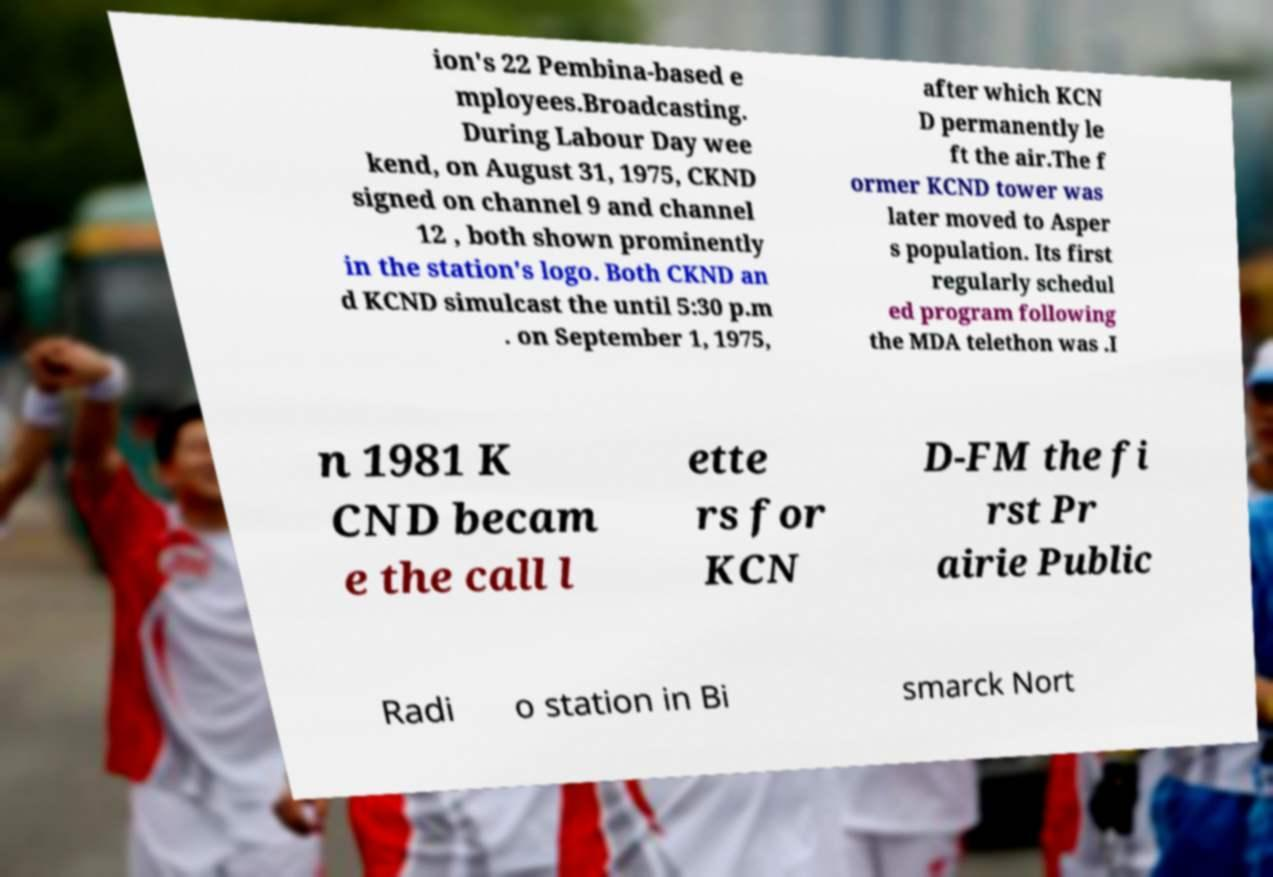What messages or text are displayed in this image? I need them in a readable, typed format. ion's 22 Pembina-based e mployees.Broadcasting. During Labour Day wee kend, on August 31, 1975, CKND signed on channel 9 and channel 12 , both shown prominently in the station's logo. Both CKND an d KCND simulcast the until 5:30 p.m . on September 1, 1975, after which KCN D permanently le ft the air.The f ormer KCND tower was later moved to Asper s population. Its first regularly schedul ed program following the MDA telethon was .I n 1981 K CND becam e the call l ette rs for KCN D-FM the fi rst Pr airie Public Radi o station in Bi smarck Nort 